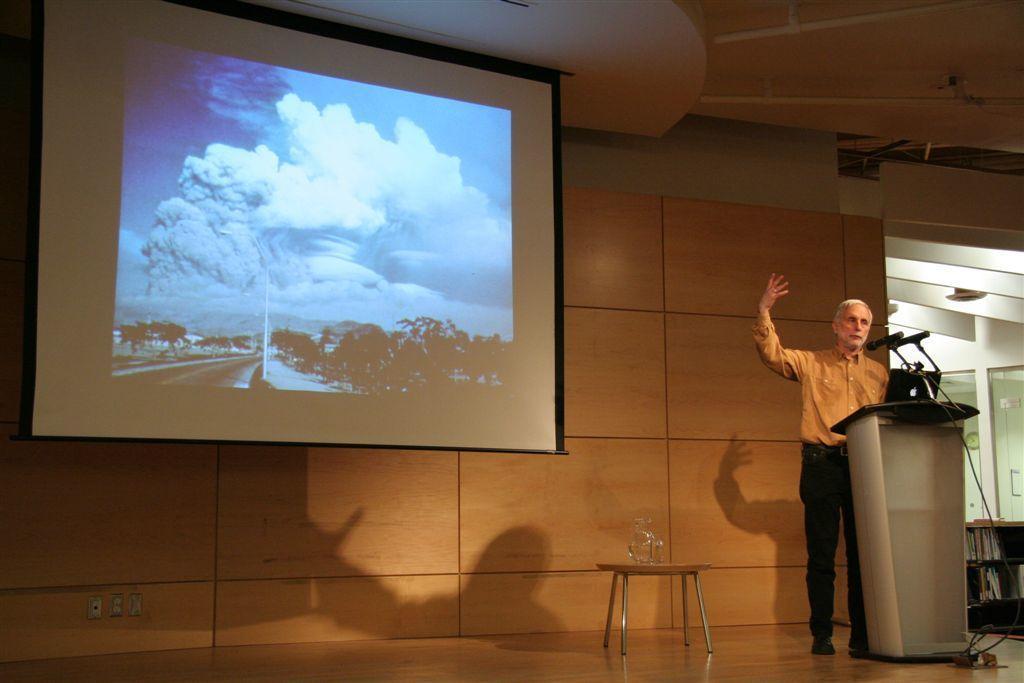Describe this image in one or two sentences. On the right side of the image we can see a man is standing in-front of the podium and talking. On the podium, we can see a laptop, mics with stands. In the background of the image we can see the wall, screen, tables, books. On the table we can see a jar. At the bottom of the image we can see a floor. At the top of the image we can see the roof. 